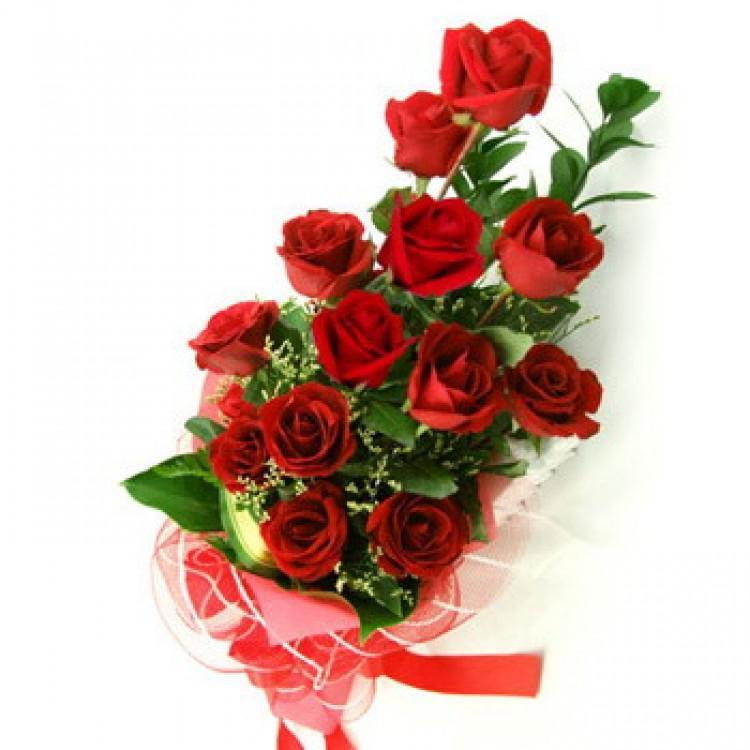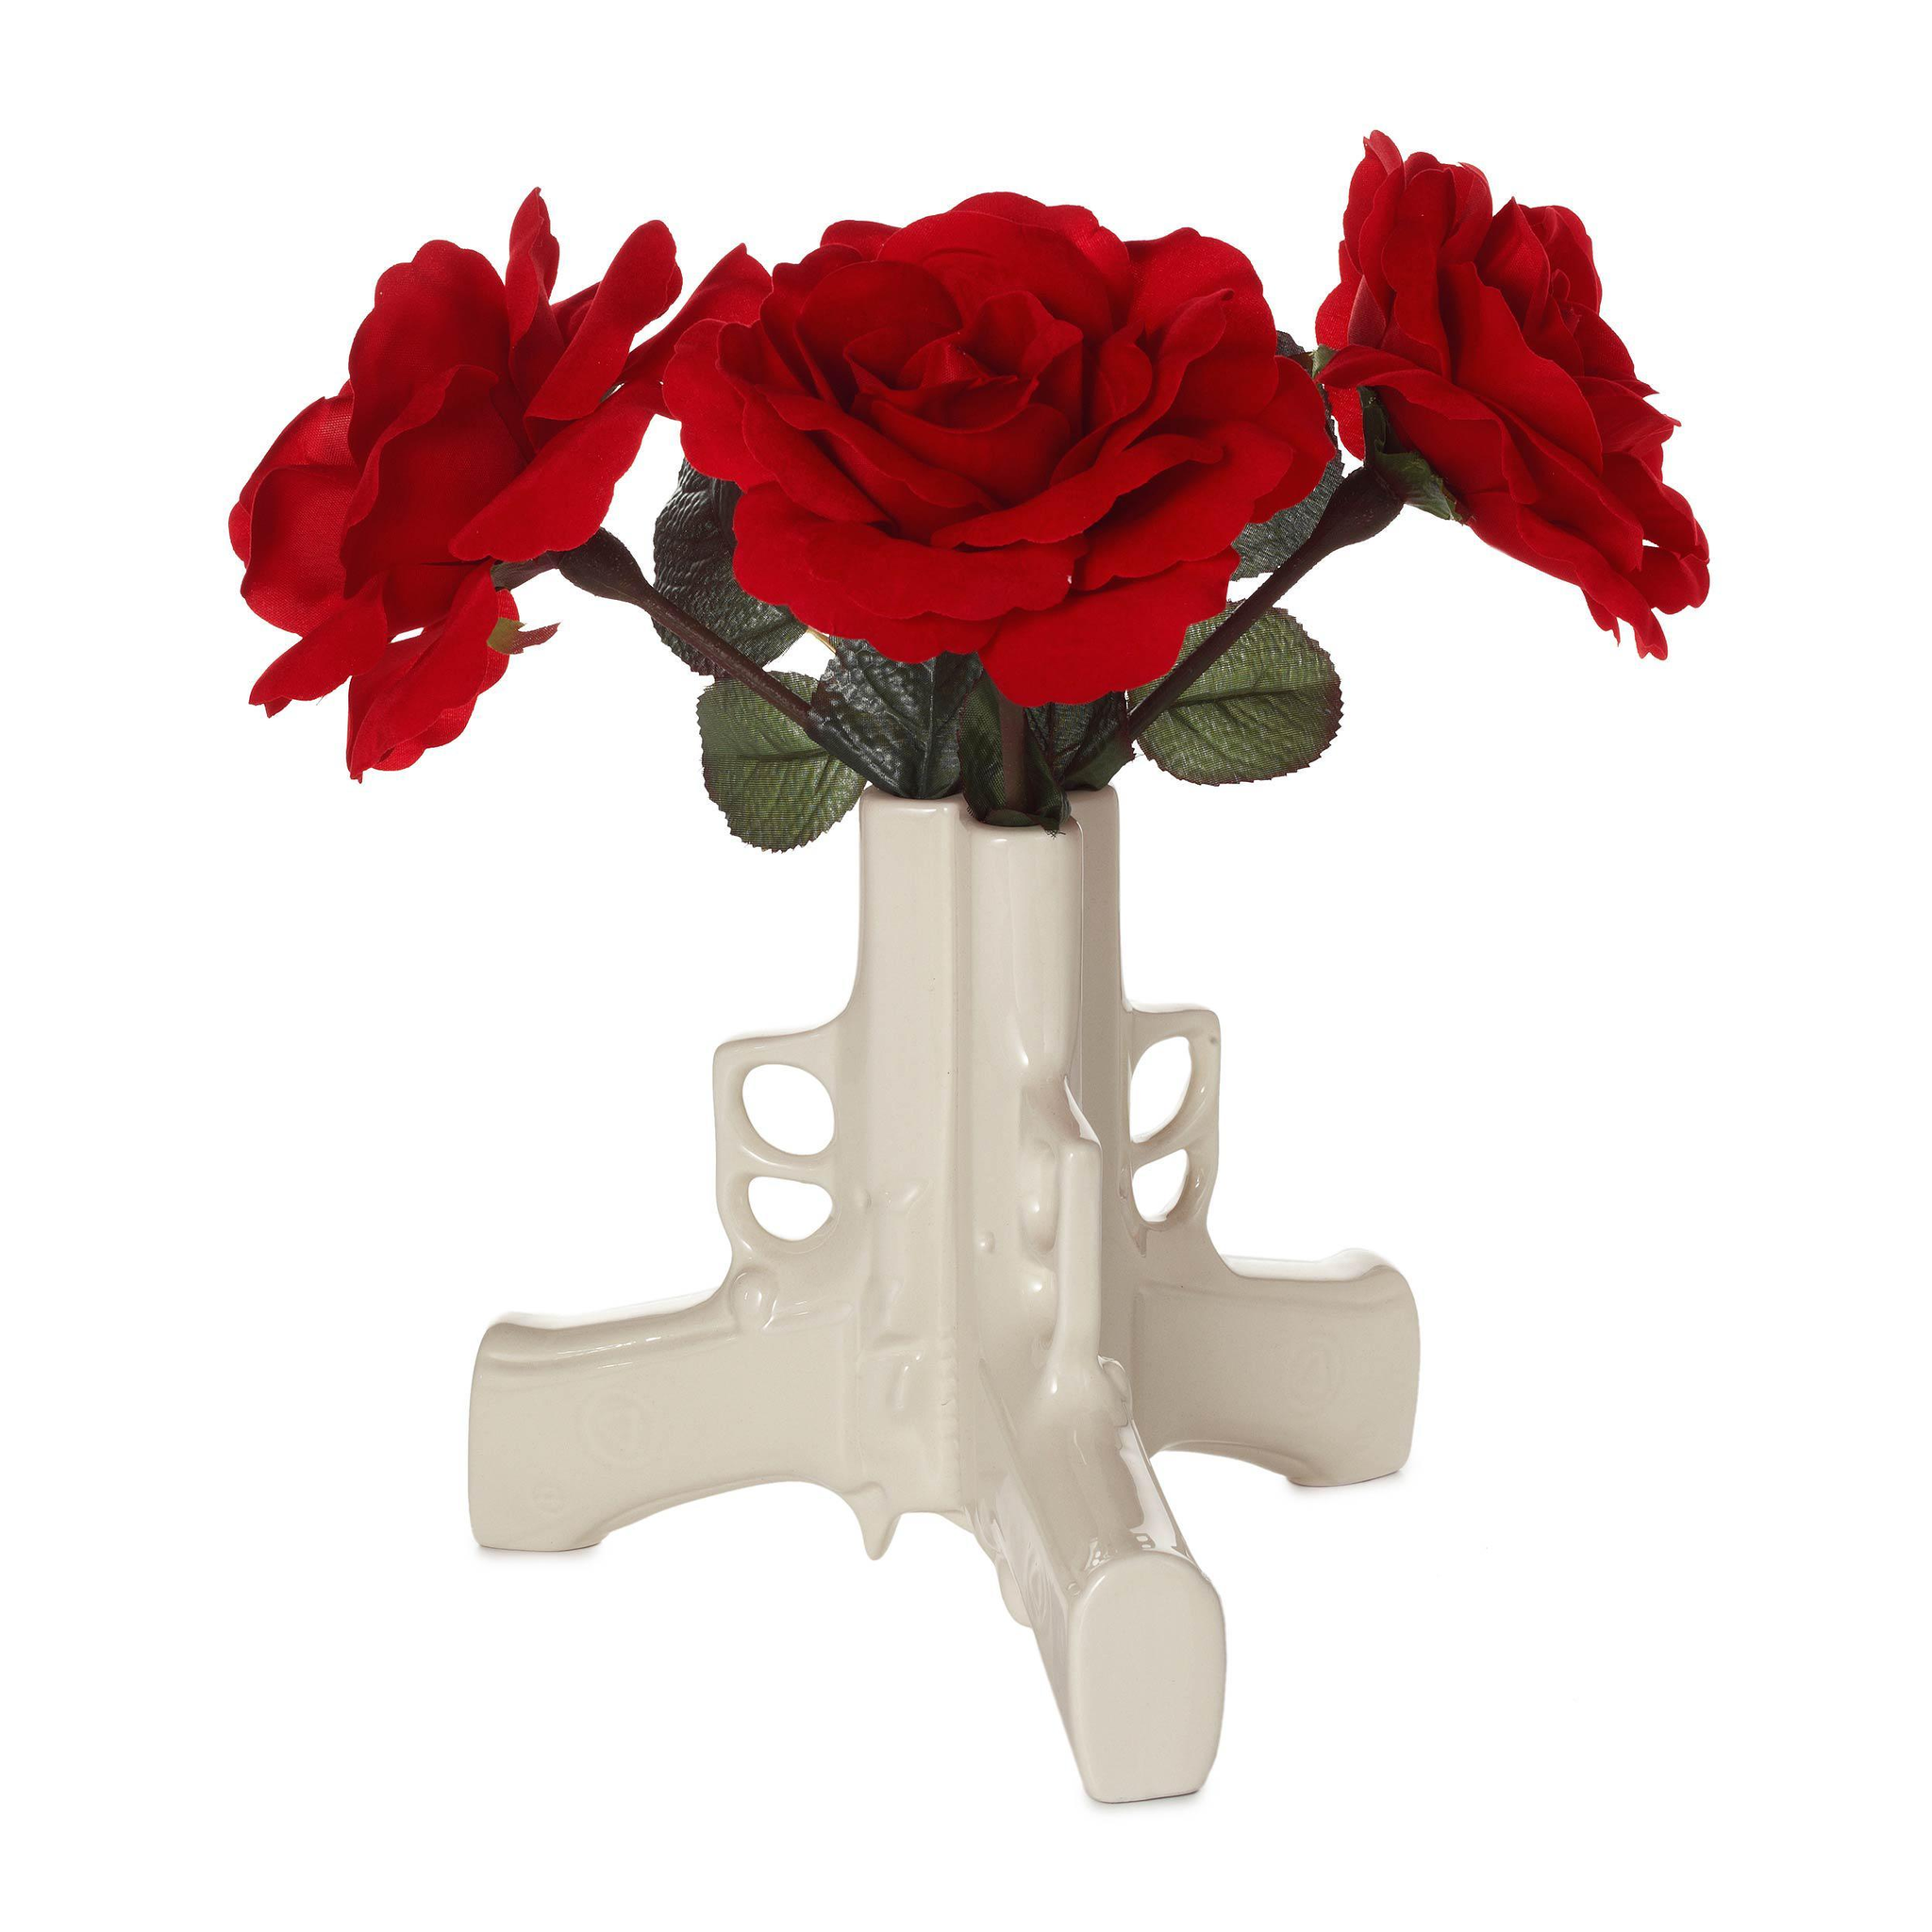The first image is the image on the left, the second image is the image on the right. Assess this claim about the two images: "there are roses in a clear glass vase that is the same width on the bottom as it is on the top". Correct or not? Answer yes or no. No. The first image is the image on the left, the second image is the image on the right. Assess this claim about the two images: "There are three flowers in a small vase.". Correct or not? Answer yes or no. Yes. 